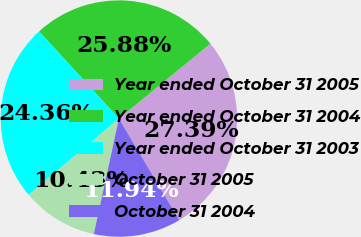Convert chart to OTSL. <chart><loc_0><loc_0><loc_500><loc_500><pie_chart><fcel>Year ended October 31 2005<fcel>Year ended October 31 2004<fcel>Year ended October 31 2003<fcel>October 31 2005<fcel>October 31 2004<nl><fcel>27.39%<fcel>25.88%<fcel>24.36%<fcel>10.43%<fcel>11.94%<nl></chart> 